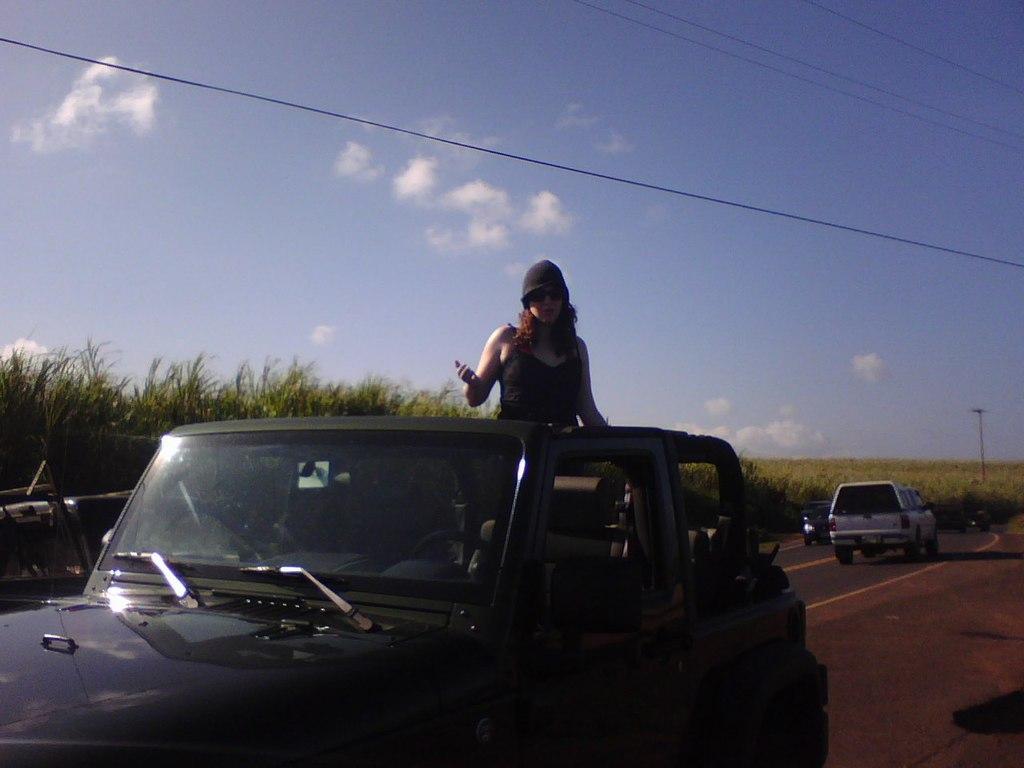How would you summarize this image in a sentence or two? In this image we can see a car on the road where a woman is standing inside the car. In the background we can see a farm, two cars and a sky with clouds. 